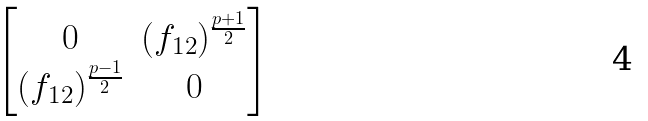<formula> <loc_0><loc_0><loc_500><loc_500>\begin{bmatrix} 0 & ( f _ { 1 2 } ) ^ { \frac { p + 1 } { 2 } } \\ ( f _ { 1 2 } ) ^ { \frac { p - 1 } { 2 } } & 0 \end{bmatrix}</formula> 